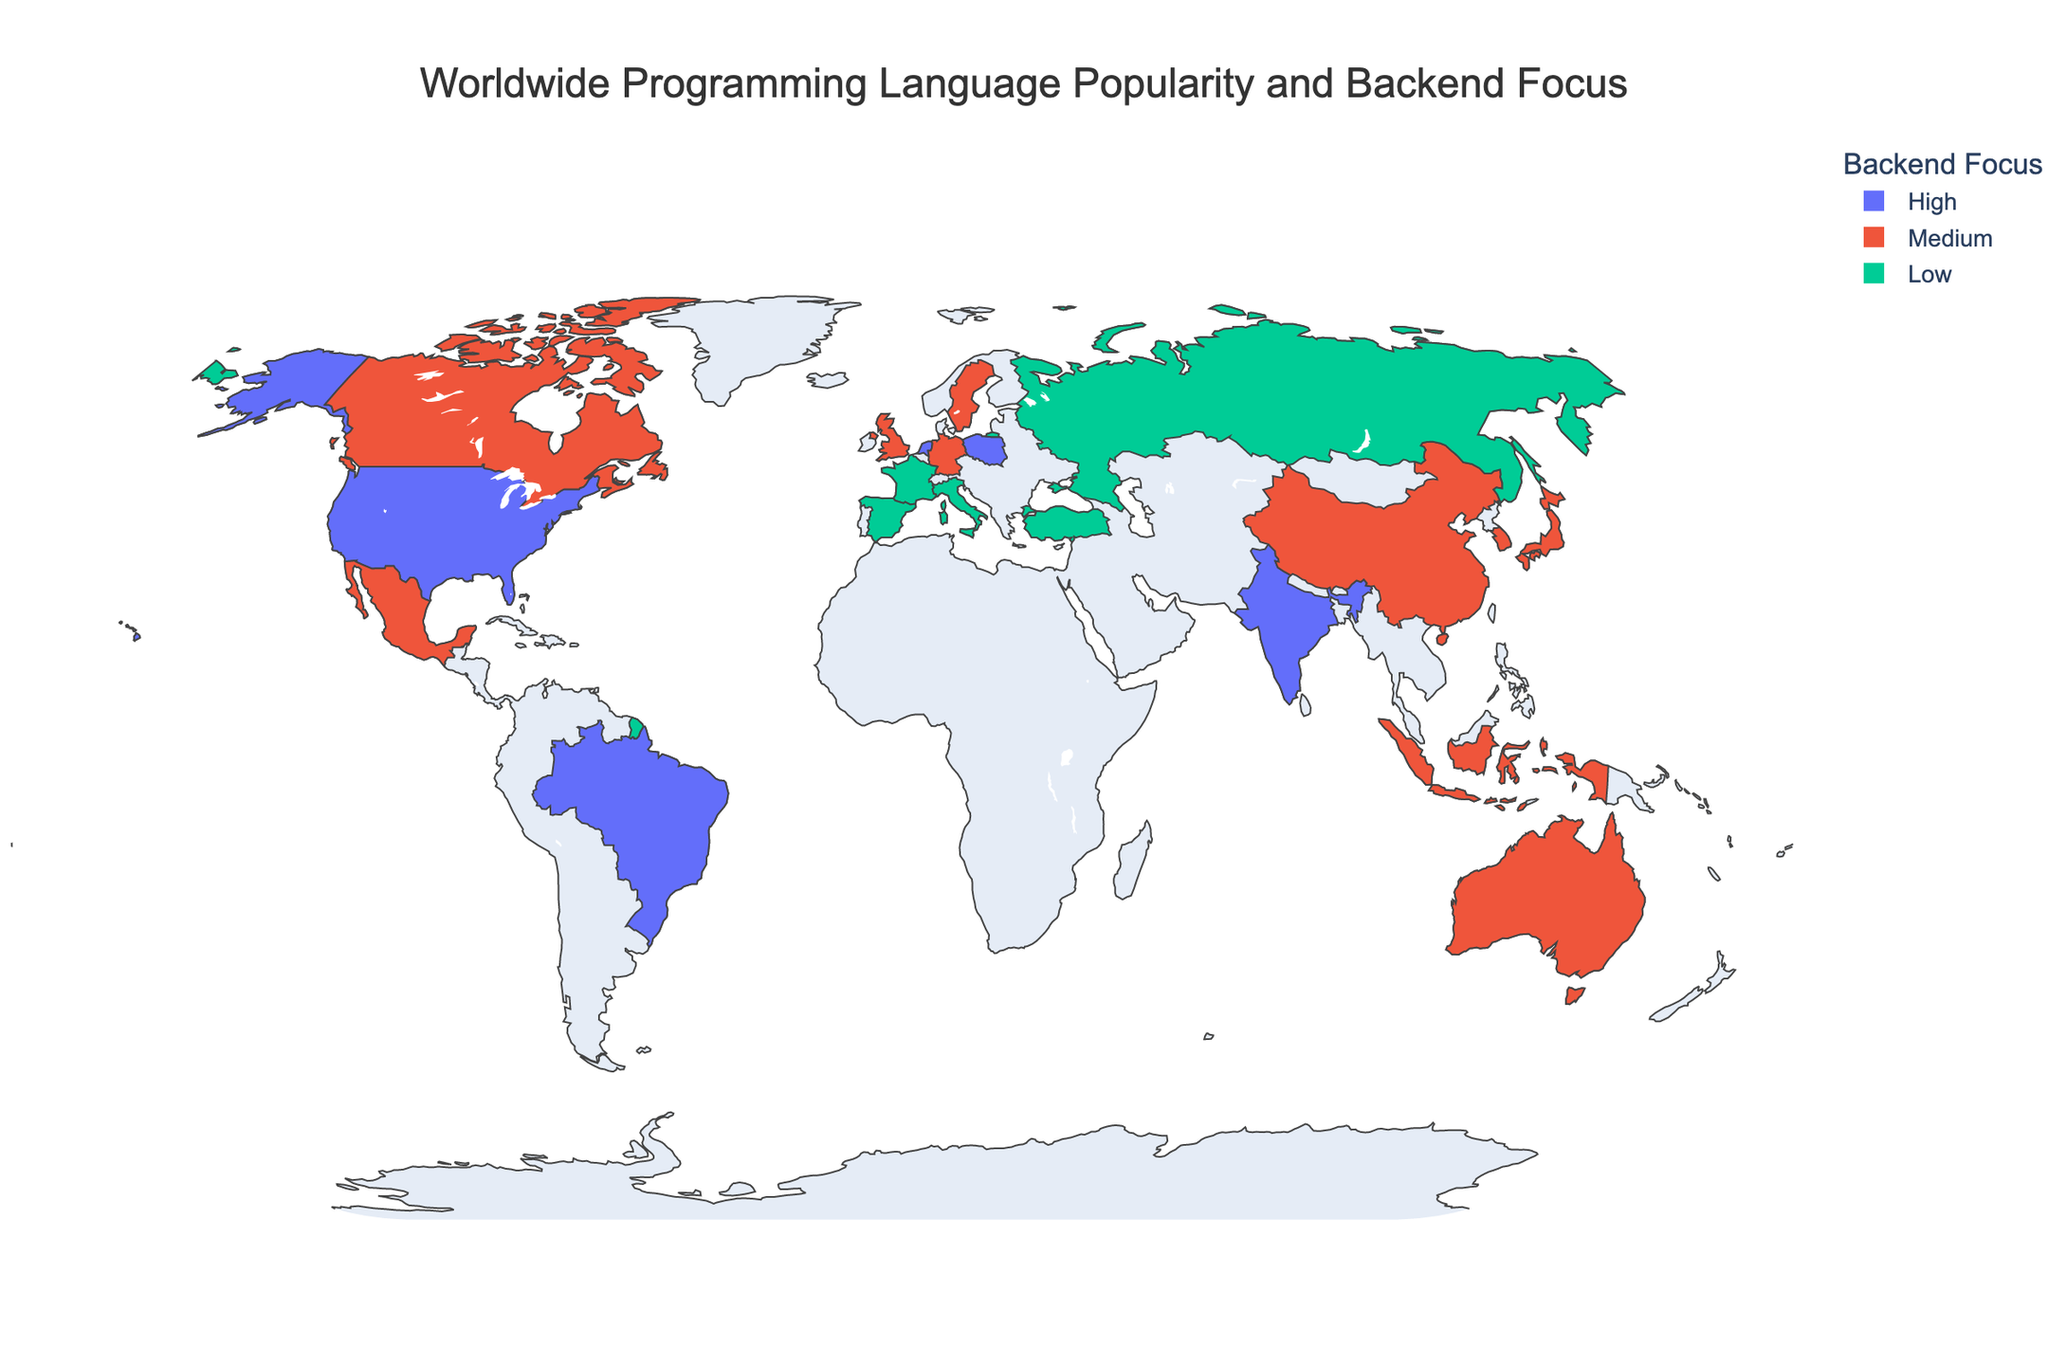What is the title of the plot? The title is usually displayed at the top of the plot in larger and bold font, indicating the main subject of the figure. It helps viewers quickly understand what the plot is about.
Answer: Worldwide Programming Language Popularity and Backend Focus Which country has the highest backend focus? To find this, look at the color intensity on the map. The country with the darkest shade represents the highest backend focus value.
Answer: USA Which countries have the lowest backend focus? Identify the countries with the lightest color shade on the map. These represent the lowest backend focus values.
Answer: Russia, France, Spain, Italy, Turkey How many countries have JavaScript as the top programming language? Count the number of countries that list JavaScript as their top language in the hover information displayed on the map.
Answer: 7 Compare the backend focus between the USA and China. Which one is higher? Check the color intensity for both the USA and China and refer to the hover data. The USA has a higher backend focus as indicated by a darker color shade.
Answer: USA Which country has Python as the top language but a low backend focus? From the hover information, identify the countries with Python as the top language, then check if their backend focus is low. Russia fits this criterion.
Answer: Russia Of the countries with a backend focus marked "Medium," which one has Java as their top language? Filter the countries with 'Medium' backend focus using color shades and then see which among them has Java as the top language in the hover information.
Answer: South Korea What's the average backend focus among Brazil, Indonesia, and Canada? The backend focus values are High (3), Medium (2), and Medium (2) respectively. Compute the average: (3 + 2 + 2) / 3 = 2.33.
Answer: 2.33 In which continent do most of the countries have JavaScript as the top language? Look for the pattern in the map where many countries in a specific continent have JavaScript as the top language in the hover information.
Answer: Europe Compare the top programming languages in Germany and Japan. Are they the same? Refer to the hover data for both Germany and Japan and compare their top programming languages. Both countries have Python as the top language.
Answer: Yes 